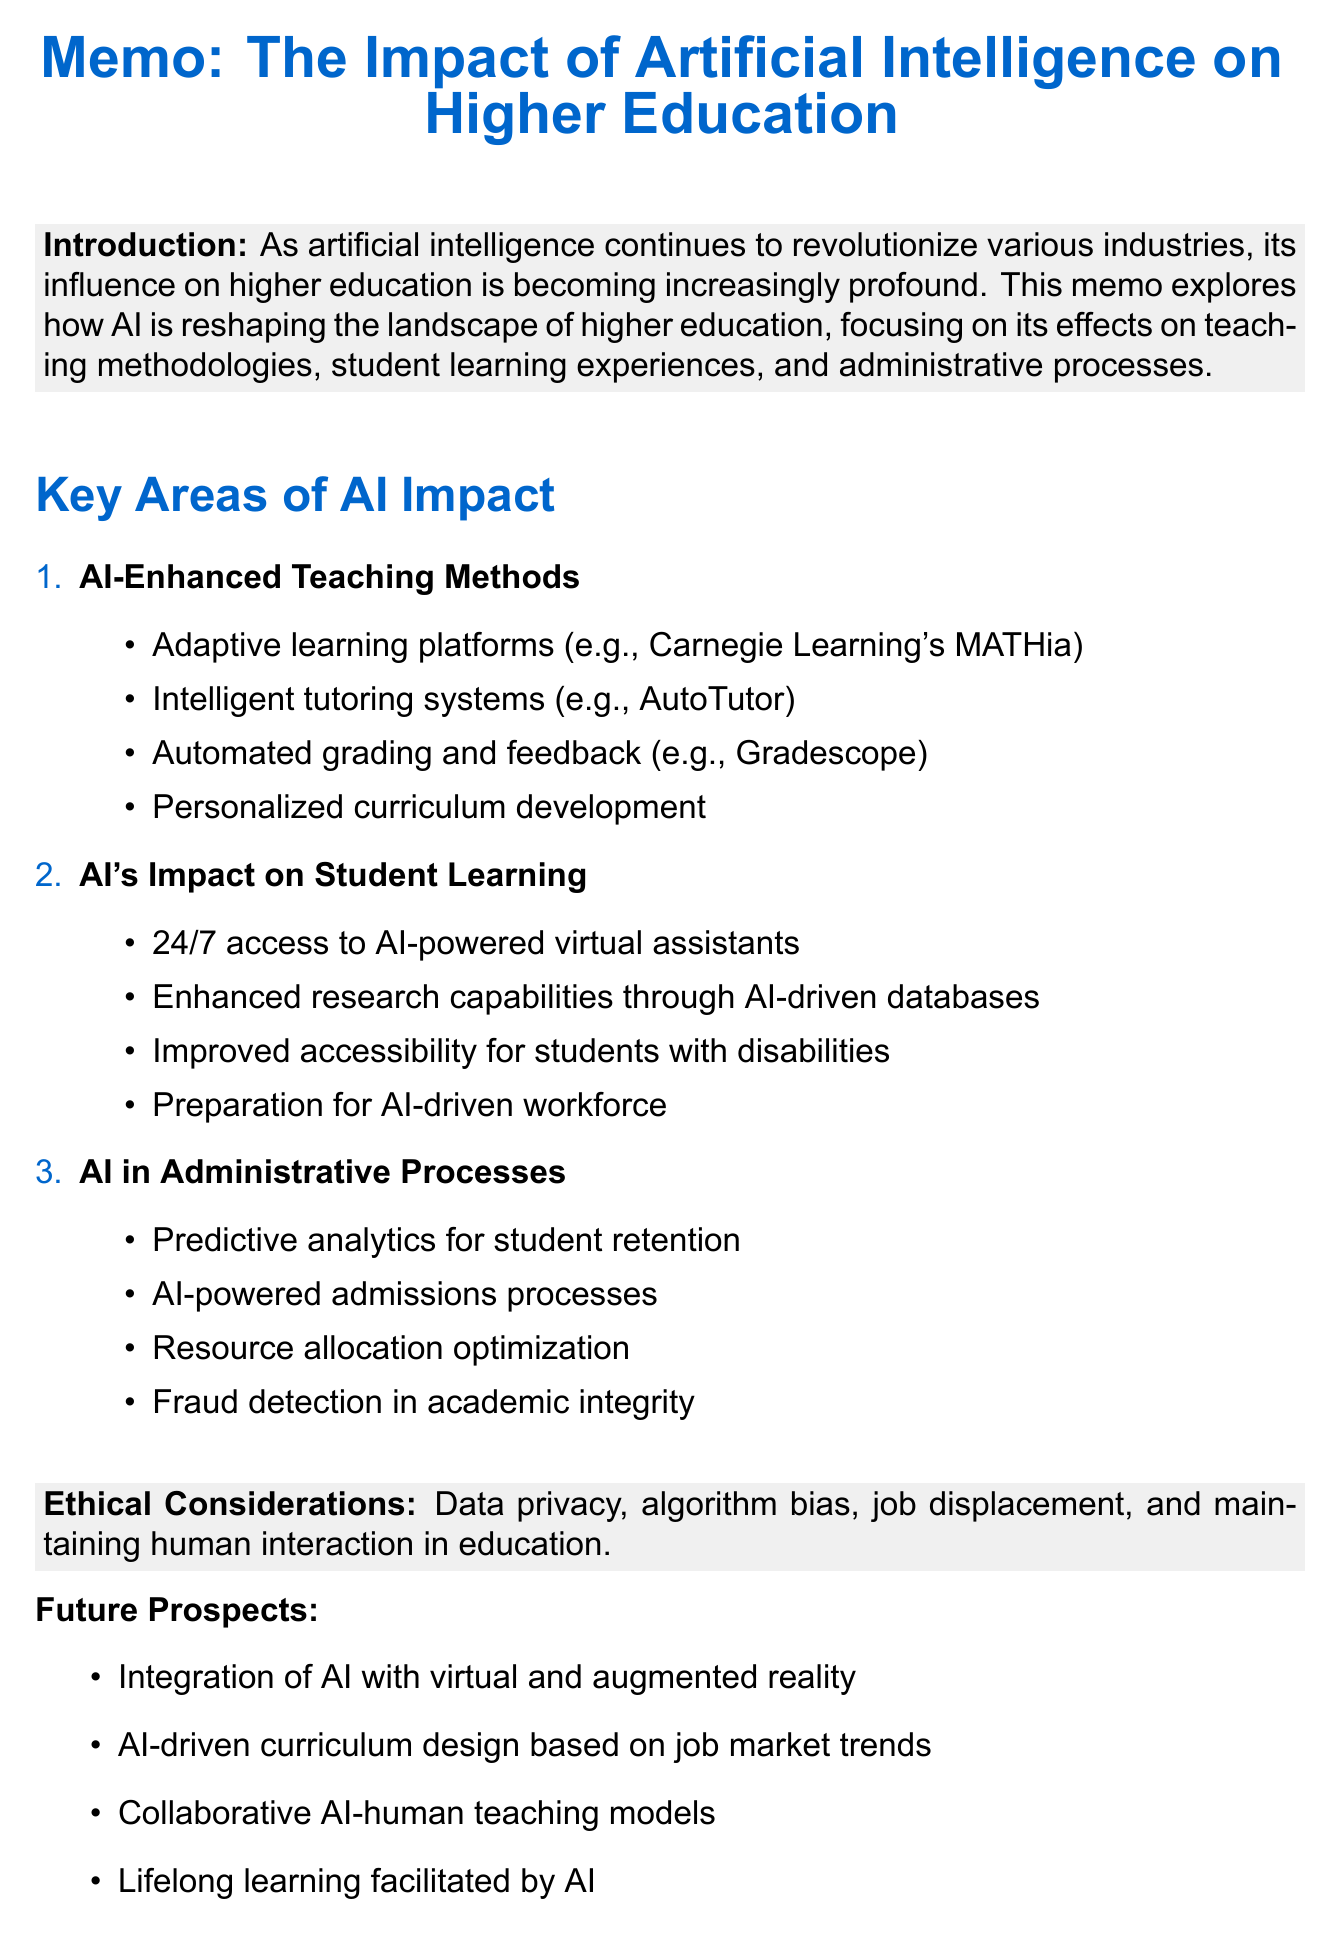What is the title of the memo? The title of the memo is explicitly stated at the beginning.
Answer: The Impact of Artificial Intelligence on Higher Education What is the main focus of the thesis? The thesis outlines the specific aspects of higher education that the essay will explore, namely teaching methodologies, student experiences, and administrative processes.
Answer: AI is reshaping the landscape of higher education What adaptive learning platform is mentioned? The document lists a specific example of an adaptive learning platform under teaching methods.
Answer: Carnegie Learning's MATHia What ethical consideration is highlighted in the document? The memo includes a section that briefly discusses various ethical concerns related to AI.
Answer: Data privacy and security concerns How many key areas of AI impact are identified? The memo outlines a specific number of areas where AI has an impact on higher education.
Answer: Three Which AI-powered tool is used for admissions processes? An example of an AI tool that improves administrative processes, particularly in admissions, is provided.
Answer: Georgia State University's chatbot What does the conclusion state about the opportunities offered by AI integration? The conclusion summarizes the implications of AI on higher education and its potential benefits.
Answer: Unprecedented opportunities for personalization, efficiency, and innovation Which future prospect involves virtual reality? A specific future prospect related to virtual reality in education is identified in the document.
Answer: Integration of AI with virtual and augmented reality in education 